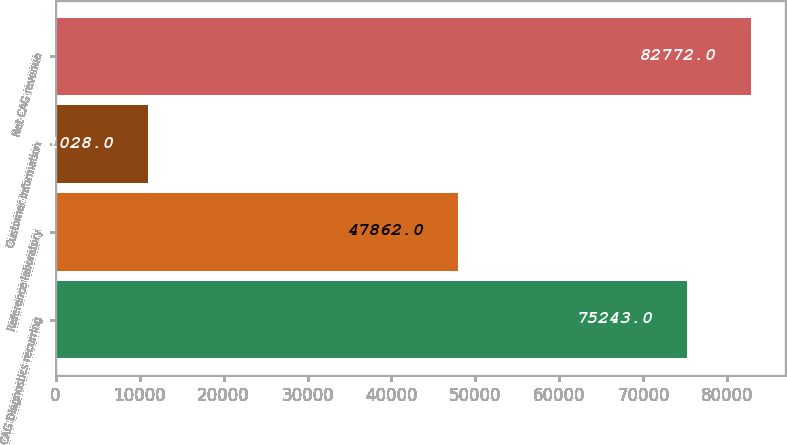Convert chart. <chart><loc_0><loc_0><loc_500><loc_500><bar_chart><fcel>CAG Diagnostics recurring<fcel>Reference laboratory<fcel>Customer information<fcel>Net CAG revenue<nl><fcel>75243<fcel>47862<fcel>11028<fcel>82772<nl></chart> 